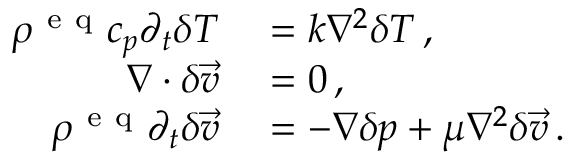<formula> <loc_0><loc_0><loc_500><loc_500>\begin{array} { r l } { \rho ^ { e q } c _ { p } \partial _ { t } \delta T } & = k \nabla ^ { 2 } \delta T \, , } \\ { \nabla \cdot \delta \vec { v } } & = 0 \, , } \\ { \rho ^ { e q } \partial _ { t } \delta \vec { v } } & = - \nabla \delta p + \mu \nabla ^ { 2 } \delta \vec { v } \, . } \end{array}</formula> 